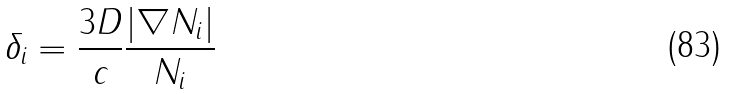<formula> <loc_0><loc_0><loc_500><loc_500>\delta _ { i } = \frac { 3 D } { c } \frac { | \nabla N _ { i } | } { N _ { i } }</formula> 